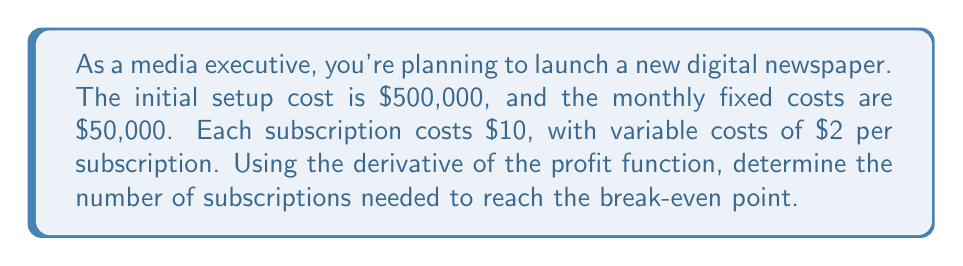Show me your answer to this math problem. Let's approach this step-by-step:

1) First, let's define our variables:
   $x$ = number of subscriptions
   $P(x)$ = profit function

2) Now, let's create our profit function:
   $$P(x) = 10x - 2x - 50000 - 500000$$
   Where:
   - $10x$ is the revenue from subscriptions
   - $2x$ is the variable cost
   - $50000$ is the monthly fixed cost
   - $500000$ is the initial setup cost

3) Simplify the function:
   $$P(x) = 8x - 550000$$

4) At the break-even point, profit is zero. So:
   $$P(x) = 0$$
   $$8x - 550000 = 0$$

5) Solve for $x$:
   $$8x = 550000$$
   $$x = 68750$$

6) To verify using derivatives, we can find where the profit function changes from negative to positive:
   $$P'(x) = 8$$

   Since $P'(x)$ is always positive, the profit is always increasing. The break-even point is where it crosses from negative to positive.

7) We can confirm this by checking the profit at 68750 subscriptions:
   $$P(68750) = 8(68750) - 550000 = 0$$

Thus, the break-even point occurs at 68,750 subscriptions.
Answer: 68,750 subscriptions 